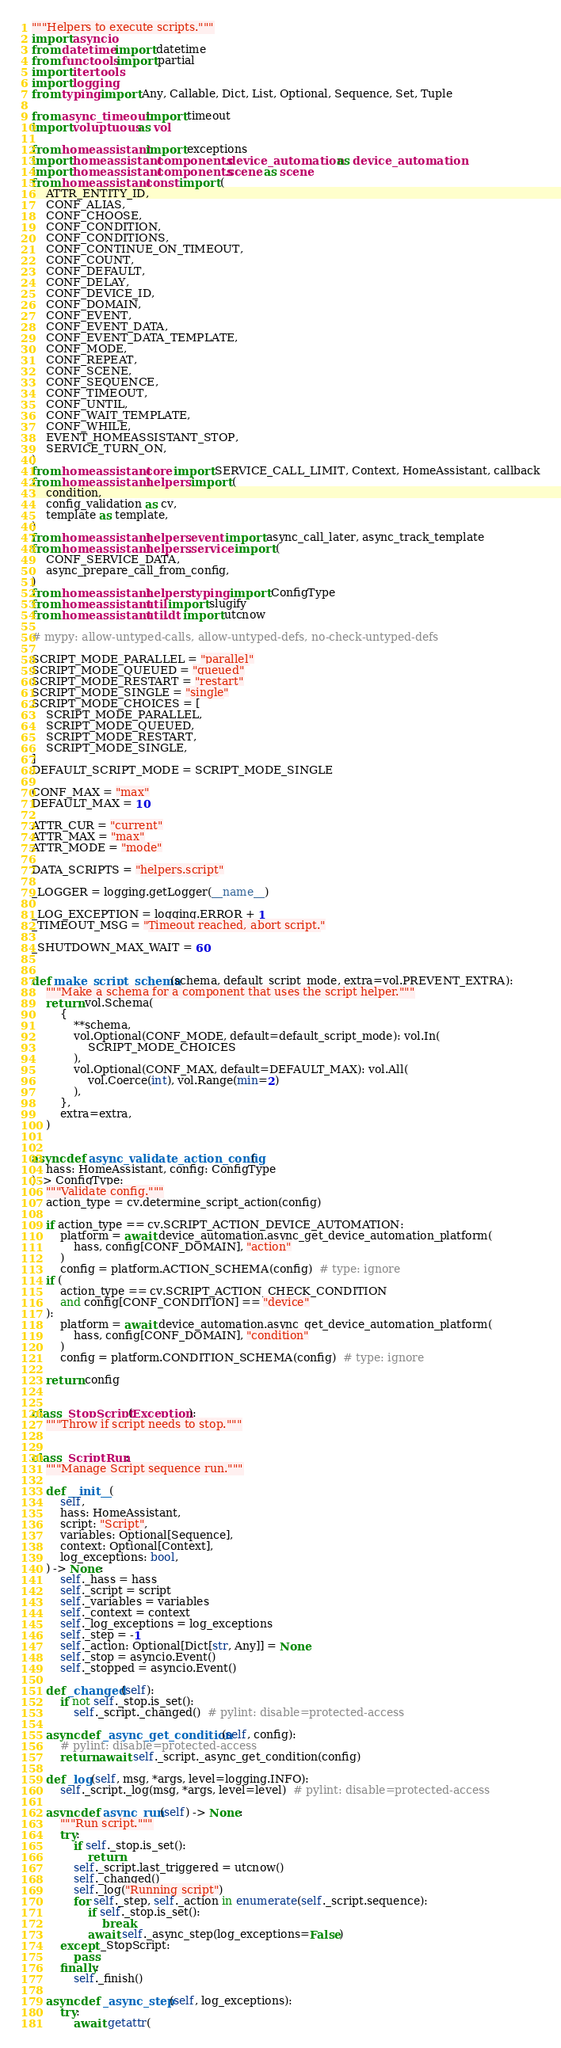<code> <loc_0><loc_0><loc_500><loc_500><_Python_>"""Helpers to execute scripts."""
import asyncio
from datetime import datetime
from functools import partial
import itertools
import logging
from typing import Any, Callable, Dict, List, Optional, Sequence, Set, Tuple

from async_timeout import timeout
import voluptuous as vol

from homeassistant import exceptions
import homeassistant.components.device_automation as device_automation
import homeassistant.components.scene as scene
from homeassistant.const import (
    ATTR_ENTITY_ID,
    CONF_ALIAS,
    CONF_CHOOSE,
    CONF_CONDITION,
    CONF_CONDITIONS,
    CONF_CONTINUE_ON_TIMEOUT,
    CONF_COUNT,
    CONF_DEFAULT,
    CONF_DELAY,
    CONF_DEVICE_ID,
    CONF_DOMAIN,
    CONF_EVENT,
    CONF_EVENT_DATA,
    CONF_EVENT_DATA_TEMPLATE,
    CONF_MODE,
    CONF_REPEAT,
    CONF_SCENE,
    CONF_SEQUENCE,
    CONF_TIMEOUT,
    CONF_UNTIL,
    CONF_WAIT_TEMPLATE,
    CONF_WHILE,
    EVENT_HOMEASSISTANT_STOP,
    SERVICE_TURN_ON,
)
from homeassistant.core import SERVICE_CALL_LIMIT, Context, HomeAssistant, callback
from homeassistant.helpers import (
    condition,
    config_validation as cv,
    template as template,
)
from homeassistant.helpers.event import async_call_later, async_track_template
from homeassistant.helpers.service import (
    CONF_SERVICE_DATA,
    async_prepare_call_from_config,
)
from homeassistant.helpers.typing import ConfigType
from homeassistant.util import slugify
from homeassistant.util.dt import utcnow

# mypy: allow-untyped-calls, allow-untyped-defs, no-check-untyped-defs

SCRIPT_MODE_PARALLEL = "parallel"
SCRIPT_MODE_QUEUED = "queued"
SCRIPT_MODE_RESTART = "restart"
SCRIPT_MODE_SINGLE = "single"
SCRIPT_MODE_CHOICES = [
    SCRIPT_MODE_PARALLEL,
    SCRIPT_MODE_QUEUED,
    SCRIPT_MODE_RESTART,
    SCRIPT_MODE_SINGLE,
]
DEFAULT_SCRIPT_MODE = SCRIPT_MODE_SINGLE

CONF_MAX = "max"
DEFAULT_MAX = 10

ATTR_CUR = "current"
ATTR_MAX = "max"
ATTR_MODE = "mode"

DATA_SCRIPTS = "helpers.script"

_LOGGER = logging.getLogger(__name__)

_LOG_EXCEPTION = logging.ERROR + 1
_TIMEOUT_MSG = "Timeout reached, abort script."

_SHUTDOWN_MAX_WAIT = 60


def make_script_schema(schema, default_script_mode, extra=vol.PREVENT_EXTRA):
    """Make a schema for a component that uses the script helper."""
    return vol.Schema(
        {
            **schema,
            vol.Optional(CONF_MODE, default=default_script_mode): vol.In(
                SCRIPT_MODE_CHOICES
            ),
            vol.Optional(CONF_MAX, default=DEFAULT_MAX): vol.All(
                vol.Coerce(int), vol.Range(min=2)
            ),
        },
        extra=extra,
    )


async def async_validate_action_config(
    hass: HomeAssistant, config: ConfigType
) -> ConfigType:
    """Validate config."""
    action_type = cv.determine_script_action(config)

    if action_type == cv.SCRIPT_ACTION_DEVICE_AUTOMATION:
        platform = await device_automation.async_get_device_automation_platform(
            hass, config[CONF_DOMAIN], "action"
        )
        config = platform.ACTION_SCHEMA(config)  # type: ignore
    if (
        action_type == cv.SCRIPT_ACTION_CHECK_CONDITION
        and config[CONF_CONDITION] == "device"
    ):
        platform = await device_automation.async_get_device_automation_platform(
            hass, config[CONF_DOMAIN], "condition"
        )
        config = platform.CONDITION_SCHEMA(config)  # type: ignore

    return config


class _StopScript(Exception):
    """Throw if script needs to stop."""


class _ScriptRun:
    """Manage Script sequence run."""

    def __init__(
        self,
        hass: HomeAssistant,
        script: "Script",
        variables: Optional[Sequence],
        context: Optional[Context],
        log_exceptions: bool,
    ) -> None:
        self._hass = hass
        self._script = script
        self._variables = variables
        self._context = context
        self._log_exceptions = log_exceptions
        self._step = -1
        self._action: Optional[Dict[str, Any]] = None
        self._stop = asyncio.Event()
        self._stopped = asyncio.Event()

    def _changed(self):
        if not self._stop.is_set():
            self._script._changed()  # pylint: disable=protected-access

    async def _async_get_condition(self, config):
        # pylint: disable=protected-access
        return await self._script._async_get_condition(config)

    def _log(self, msg, *args, level=logging.INFO):
        self._script._log(msg, *args, level=level)  # pylint: disable=protected-access

    async def async_run(self) -> None:
        """Run script."""
        try:
            if self._stop.is_set():
                return
            self._script.last_triggered = utcnow()
            self._changed()
            self._log("Running script")
            for self._step, self._action in enumerate(self._script.sequence):
                if self._stop.is_set():
                    break
                await self._async_step(log_exceptions=False)
        except _StopScript:
            pass
        finally:
            self._finish()

    async def _async_step(self, log_exceptions):
        try:
            await getattr(</code> 